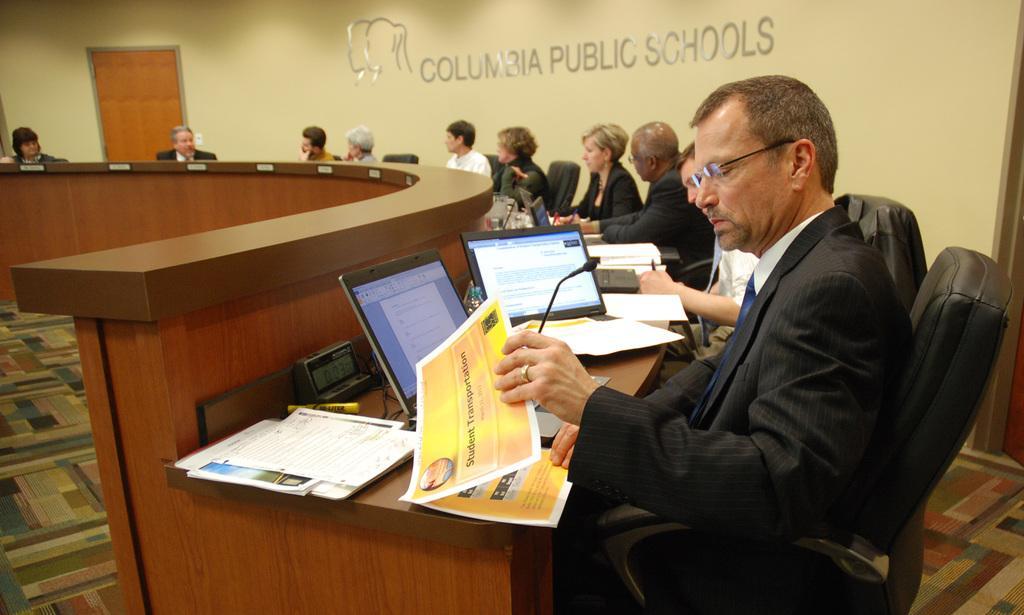Please provide a concise description of this image. In this picture we can see laptops, papers, marker and the objects on the table. We can see a person sitting on the chair and holding a paper. There is a person holding a pen in his hand. We can see a few people sitting on the chair from left to right. We can see a some text on a cream surface and a door in the background. 